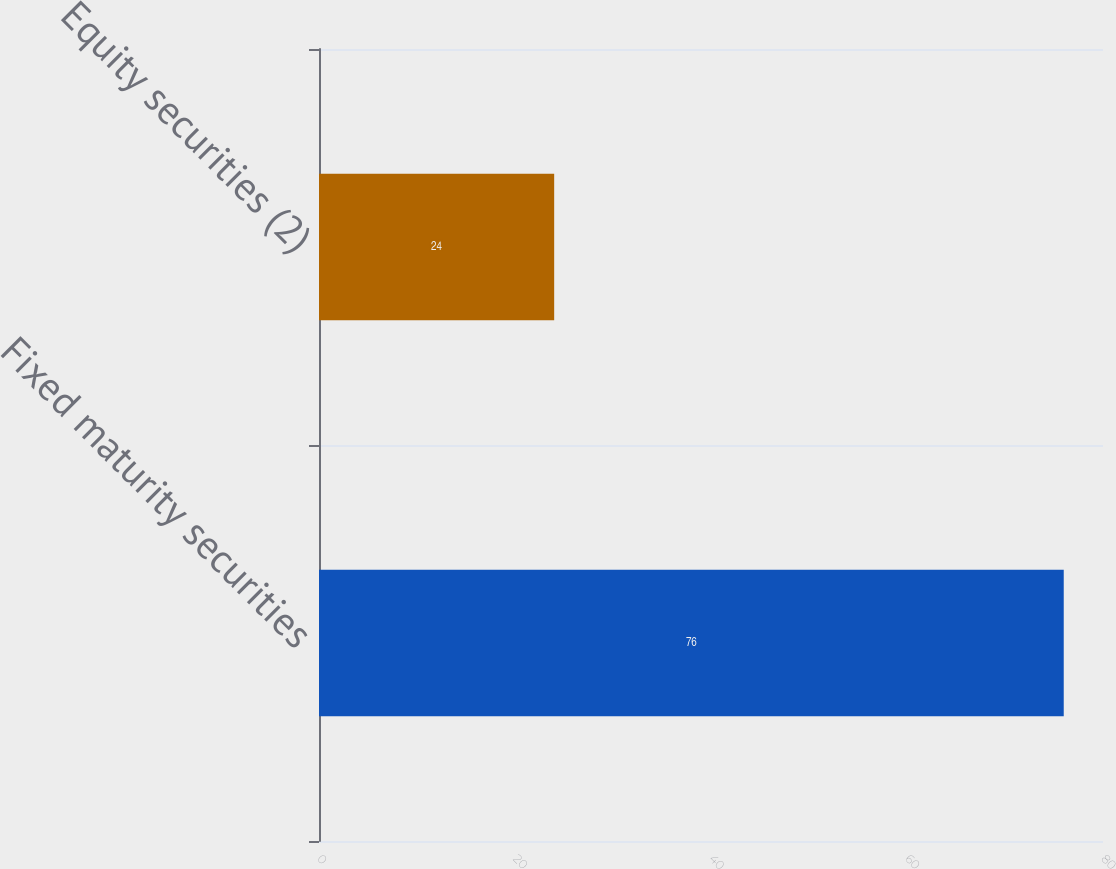<chart> <loc_0><loc_0><loc_500><loc_500><bar_chart><fcel>Fixed maturity securities<fcel>Equity securities (2)<nl><fcel>76<fcel>24<nl></chart> 